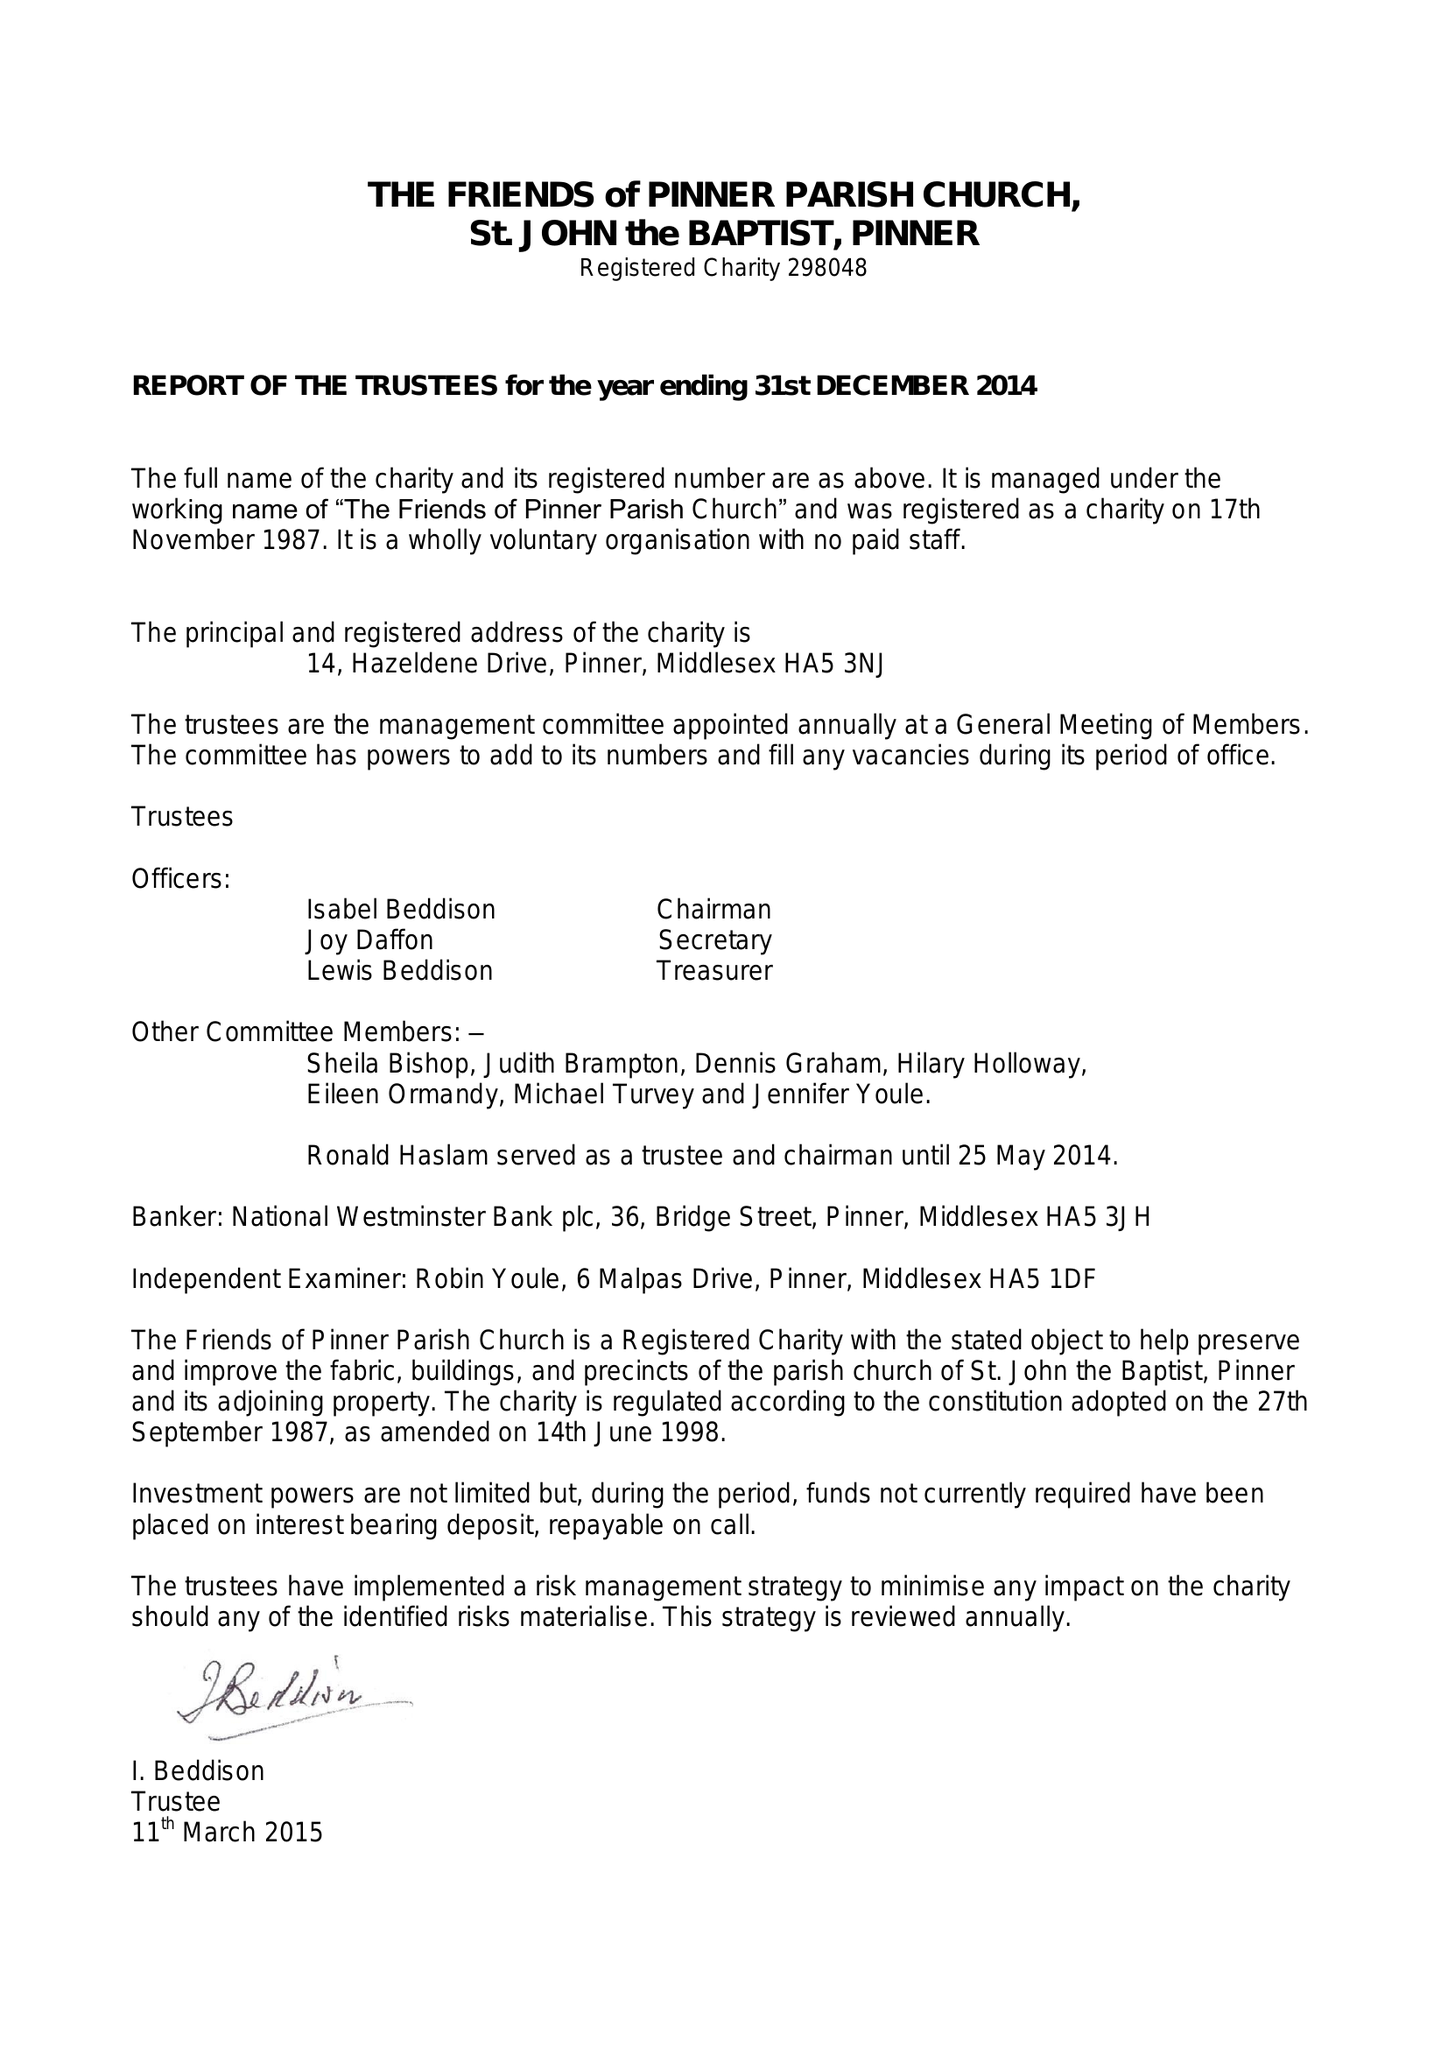What is the value for the charity_name?
Answer the question using a single word or phrase. The Friends Of Pinner Parish Church, St John The Baptist, Pinner 